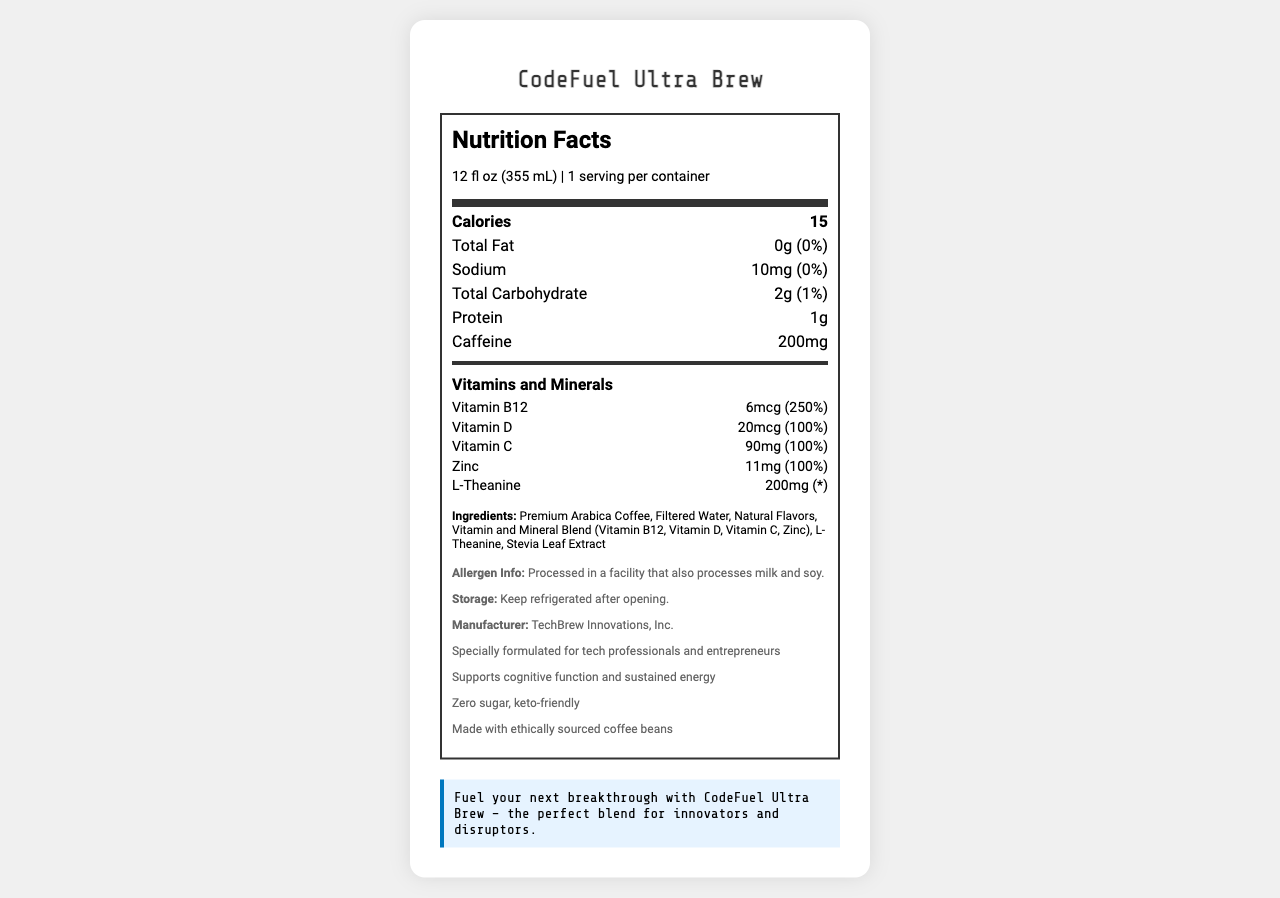what is the serving size of CodeFuel Ultra Brew? The serving size is mentioned right below the Nutrition Facts title in the serving info section.
Answer: 12 fl oz (355 mL) how many calories are in one serving of CodeFuel Ultra Brew? The number of calories is highlighted in the bold nutrient row under "Calories".
Answer: 15 what is the amount of caffeine in CodeFuel Ultra Brew? The amount of caffeine is listed in the nutrient row specifically labeled "Caffeine".
Answer: 200mg how much sodium does one serving contain? The sodium amount is given in the nutrient row labeled "Sodium".
Answer: 10mg what percentage of the daily value of Vitamin D does CodeFuel Ultra Brew provide? The daily value percentage for Vitamin D is noted next to its amount under Vitamins and Minerals.
Answer: 100% what types of vitamins and minerals are included in CodeFuel Ultra Brew? A. Vitamin A, Vitamin C, Magnesium B. Vitamin B12, Vitamin D, Vitamin C, Zinc C. Calcium, Iron, Vitamin E The vitamins and minerals mentioned in the document include Vitamin B12, Vitamin D, Vitamin C, and Zinc.
Answer: B. Vitamin B12, Vitamin D, Vitamin C, Zinc which ingredient is used as a sweetener in CodeFuel Ultra Brew? A. Sugar B. Stevia Leaf Extract C. Aspartame Under the ingredients section, it mentions that Stevia Leaf Extract is used.
Answer: B. Stevia Leaf Extract is CodeFuel Ultra Brew sugar-free? The description in the additional information section mentions "Zero sugar".
Answer: Yes can it be determined from the document if CodeFuel Ultra Brew contains gluten? The document does not provide information on whether the product contains gluten.
Answer: Cannot be determined how should CodeFuel Ultra Brew be stored after opening? The storage instructions in the additional information clearly state to keep it refrigerated after opening.
Answer: Keep refrigerated after opening what is a potential allergen mentioned in the document? The allergen info section mentions that it is processed in a facility that also processes milk and soy.
Answer: Milk and soy what is the main idea of the document? The document comprehensively summarizes all relevant information about the product, including its nutritional content, ingredients, and purpose.
Answer: The document is a detailed Nutrition Facts label for CodeFuel Ultra Brew, a vitamin-fortified coffee blend designed for tech professionals and entrepreneurs. It provides nutritional information, ingredients, storage instructions, allergen warnings, and additional benefits of the product. 